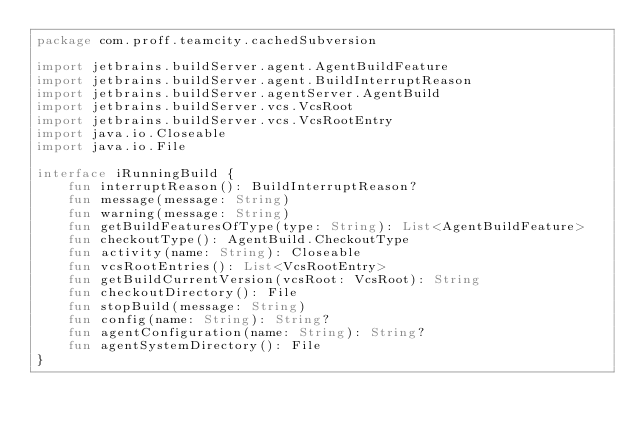Convert code to text. <code><loc_0><loc_0><loc_500><loc_500><_Kotlin_>package com.proff.teamcity.cachedSubversion

import jetbrains.buildServer.agent.AgentBuildFeature
import jetbrains.buildServer.agent.BuildInterruptReason
import jetbrains.buildServer.agentServer.AgentBuild
import jetbrains.buildServer.vcs.VcsRoot
import jetbrains.buildServer.vcs.VcsRootEntry
import java.io.Closeable
import java.io.File

interface iRunningBuild {
    fun interruptReason(): BuildInterruptReason?
    fun message(message: String)
    fun warning(message: String)
    fun getBuildFeaturesOfType(type: String): List<AgentBuildFeature>
    fun checkoutType(): AgentBuild.CheckoutType
    fun activity(name: String): Closeable
    fun vcsRootEntries(): List<VcsRootEntry>
    fun getBuildCurrentVersion(vcsRoot: VcsRoot): String
    fun checkoutDirectory(): File
    fun stopBuild(message: String)
    fun config(name: String): String?
    fun agentConfiguration(name: String): String?
    fun agentSystemDirectory(): File
}</code> 